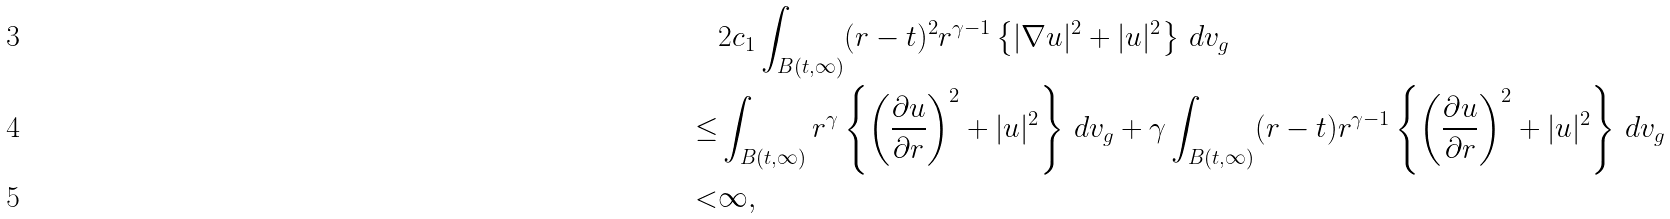Convert formula to latex. <formula><loc_0><loc_0><loc_500><loc_500>& 2 c _ { 1 } \int _ { B ( t , \infty ) } ( r - t ) ^ { 2 } r ^ { \gamma - 1 } \left \{ | \nabla u | ^ { 2 } + | u | ^ { 2 } \right \} \, d v _ { g } \\ \leq & \int _ { B ( t , \infty ) } r ^ { \gamma } \left \{ \left ( \frac { \partial u } { \partial r } \right ) ^ { 2 } + | u | ^ { 2 } \right \} \, d v _ { g } + \gamma \int _ { B ( t , \infty ) } ( r - t ) r ^ { \gamma - 1 } \left \{ \left ( \frac { \partial u } { \partial r } \right ) ^ { 2 } + | u | ^ { 2 } \right \} \, d v _ { g } \\ < & \infty ,</formula> 